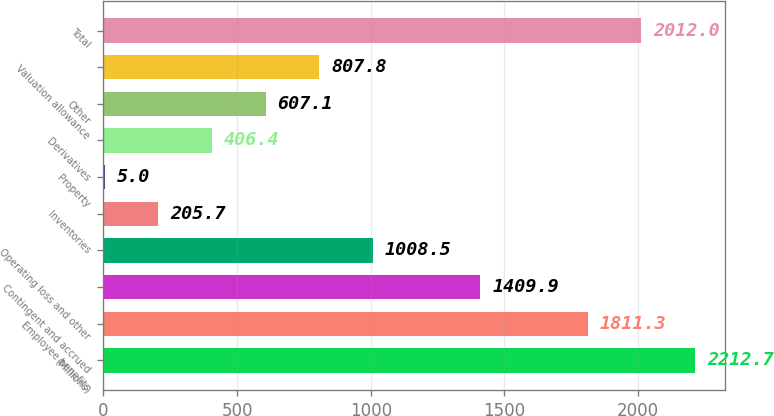Convert chart to OTSL. <chart><loc_0><loc_0><loc_500><loc_500><bar_chart><fcel>(Millions)<fcel>Employee benefits<fcel>Contingent and accrued<fcel>Operating loss and other<fcel>Inventories<fcel>Property<fcel>Derivatives<fcel>Other<fcel>Valuation allowance<fcel>Total<nl><fcel>2212.7<fcel>1811.3<fcel>1409.9<fcel>1008.5<fcel>205.7<fcel>5<fcel>406.4<fcel>607.1<fcel>807.8<fcel>2012<nl></chart> 